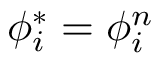<formula> <loc_0><loc_0><loc_500><loc_500>\phi _ { i } ^ { * } = \phi _ { i } ^ { n }</formula> 